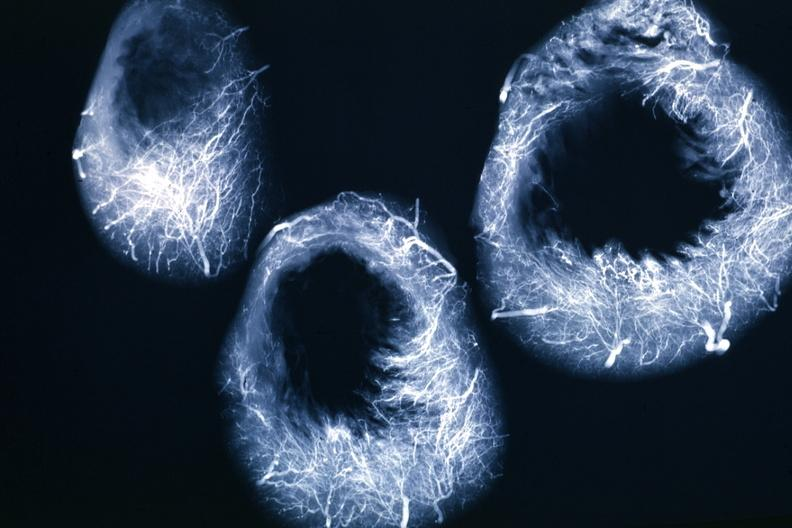what is present?
Answer the question using a single word or phrase. Cardiovascular 